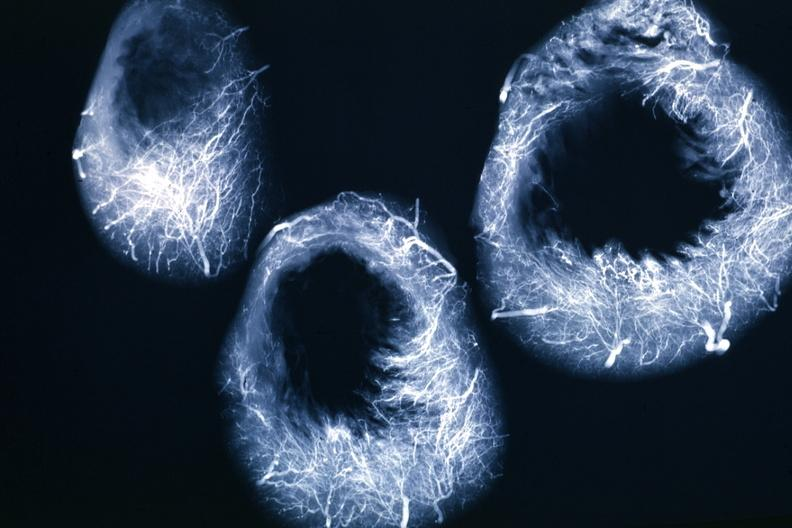what is present?
Answer the question using a single word or phrase. Cardiovascular 